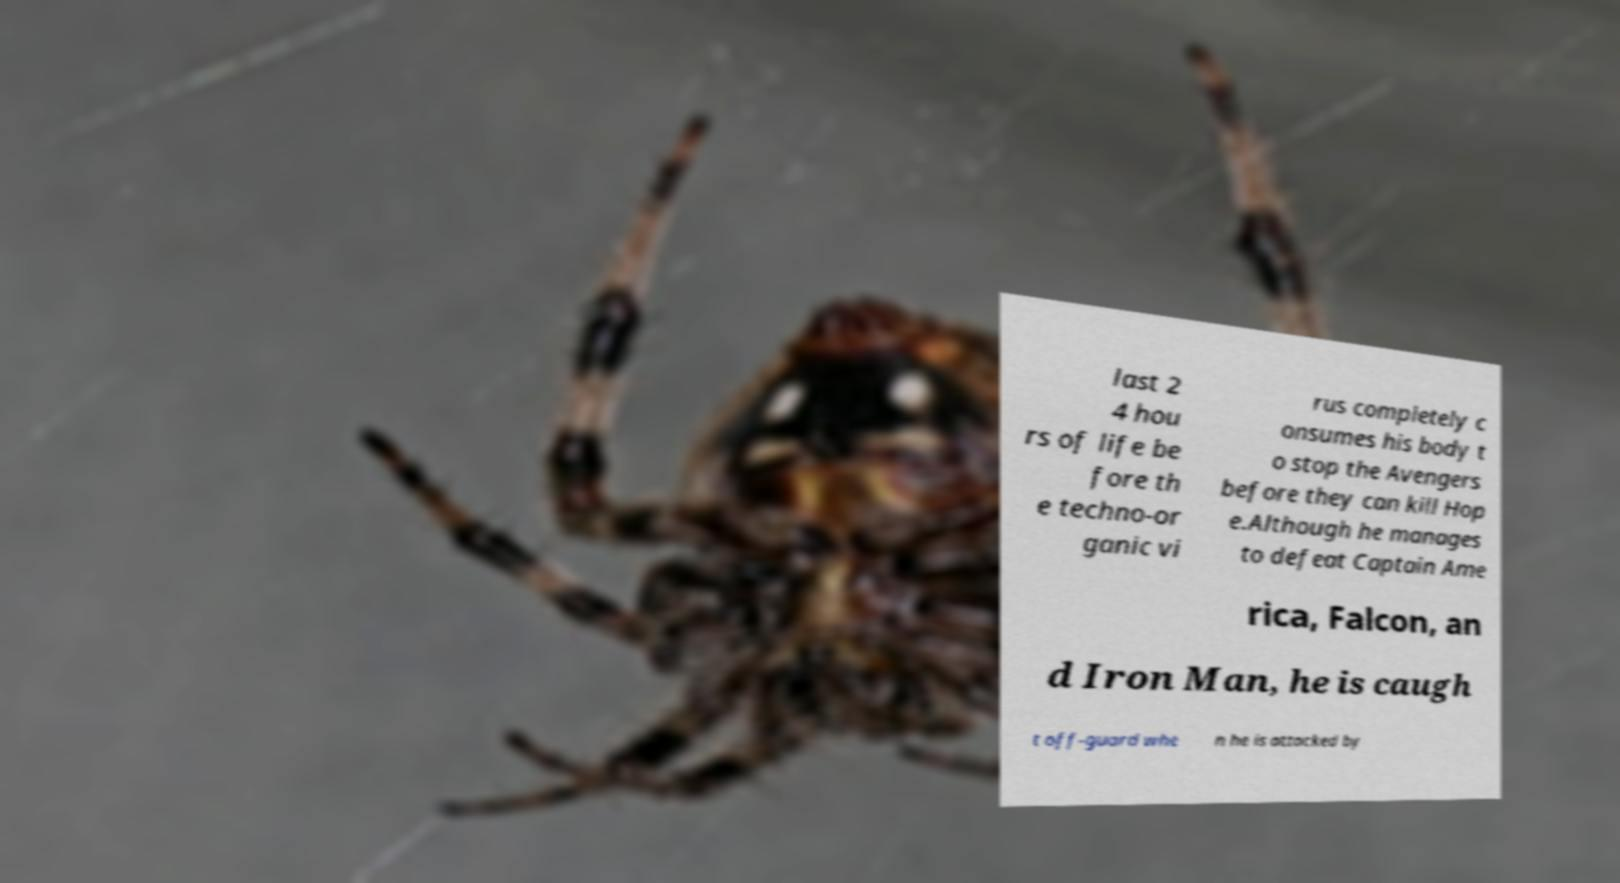Can you accurately transcribe the text from the provided image for me? last 2 4 hou rs of life be fore th e techno-or ganic vi rus completely c onsumes his body t o stop the Avengers before they can kill Hop e.Although he manages to defeat Captain Ame rica, Falcon, an d Iron Man, he is caugh t off-guard whe n he is attacked by 